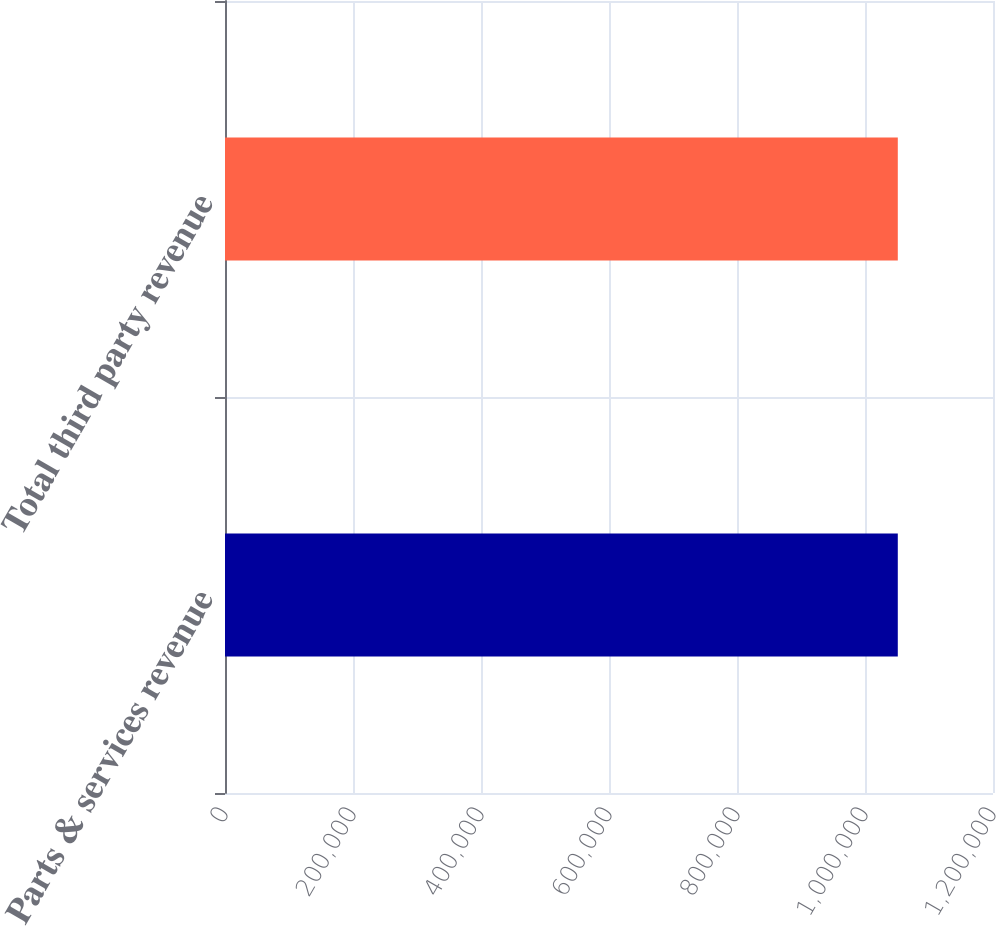Convert chart to OTSL. <chart><loc_0><loc_0><loc_500><loc_500><bar_chart><fcel>Parts & services revenue<fcel>Total third party revenue<nl><fcel>1.05125e+06<fcel>1.05125e+06<nl></chart> 